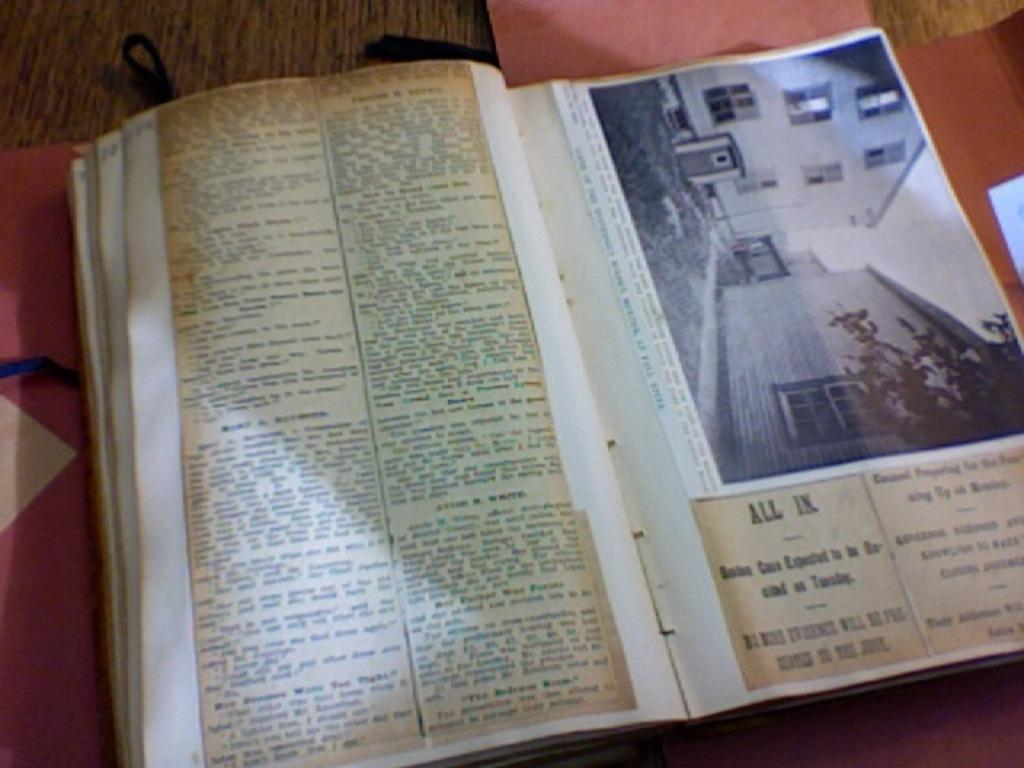Provide a one-sentence caption for the provided image. A book of newspaper clippings. One of the headlines reads All In. 